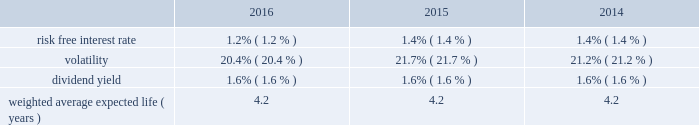Fidelity national information services , inc .
And subsidiaries notes to consolidated financial statements - ( continued ) ( a ) intrinsic value is based on a closing stock price as of december 31 , 2016 of $ 75.64 .
The weighted average fair value of options granted during the years ended december 31 , 2016 , 2015 and 2014 was estimated to be $ 9.35 , $ 10.67 and $ 9.15 , respectively , using the black-scholes option pricing model with the assumptions below: .
The company estimates future forfeitures at the time of grant and revises those estimates in subsequent periods if actual forfeitures differ from those estimates .
The company bases the risk-free interest rate that is used in the stock option valuation model on u.s .
N treasury securities issued with maturities similar to the expected term of the options .
The expected stock volatility factor is determined using historical daily price changes of the company's common stock over the most recent period commensurate with the expected term of the option and the impact of any expected trends .
The dividend yield assumption is based on the current dividend yield at the grant tt date or management's forecasted expectations .
The expected life assumption is determined by calculating the average term from the tt company's historical stock option activity and considering the impact of expected future trends .
The company granted a total of 1 million restricted stock shares at prices ranging from $ 56.44 to $ 79.41 on various dates in 2016 .
The company granted a total of 1 million restricted stock shares at prices ranging from $ 61.33 to $ 69.33 on various dates in 20t 15 .
The company granted a total of 1 million restricted stock shares at prices ranging from $ 52.85 to $ 64.04 on various dates in 2014 .
These shares were granted at the closing market price on the date of grant and vest annually over three years .
As of december 31 , 2016 and 2015 , we have approximately 3 million and 4 million unvested restricted shares remaining .
The december 31 , 2016 balance includes those rsu's converted in connection with the sungard acquisition as noted above .
The company has provided for total stock compensation expense of $ 137 million , $ 98 million and $ 56 million for the years ended december 31 , 2016 , 2015 and 2014 , respectively , which is included in selling , general , and administrative expense in the consolidated statements of earnings , unless the expense is attributable to a discontinued operation .
Of the total stock compensation expense , $ 2 million for 2014 relates to liability based awards that will not be credited to additional paid in capital until issued .
Total d compensation expense for 2016 and 2015 did not include amounts relating to liability based awards .
As of december 31 , 2016 and 2015 , the total unrecognized compensation cost related to non-vested stock awards is $ 141 million and $ 206 million , respectively , which is expected to be recognized in pre-tax income over a weighted average period of 1.4 years and 1.6 years , respectively .
German pension plans our german operations have unfunded , defined benefit plan obligations .
These obligations relate to benefits to be paid to germanaa employees upon retirement .
The accumulated benefit obligation as of december 31 , 2016 and 2015 , was $ 49 million and $ 48 million , respectively , and the projected benefit obligation was $ 50 million and $ 49 million , respectively .
The plan remains unfunded as of december 31 , 2016 .
( 15 ) divestitures and discontinued operations on december 7 , 2016 , the company entered into a definitive agreement to sell the sungard public sector and education ( "ps&e" ) businesses for $ 850 million .
The transaction included all ps&e solutions , which provide a comprehensive set of technology solutions to address public safety and public administration needs of government entities as well asn the needs of k-12 school districts .
The divestiture is consistent with our strategy to serve the financial services markets .
We received cash proceeds , net of taxes and transaction-related expenses of approximately $ 500 million .
Net cash proceeds are expected to be used to reduce outstanding debt ( see note 10 ) .
The ps&e businesses are included in the corporate and other segment .
The transaction closed on february 1 , 2017 , resulting in an expected pre-tax gain ranging from $ 85 million to $ 90 million that will .
What is the percentage increase in the fair value of of options from 2015 to 2016? 
Computations: ((9.35 - 10.67) / 10.67)
Answer: -0.12371. Fidelity national information services , inc .
And subsidiaries notes to consolidated financial statements - ( continued ) ( a ) intrinsic value is based on a closing stock price as of december 31 , 2016 of $ 75.64 .
The weighted average fair value of options granted during the years ended december 31 , 2016 , 2015 and 2014 was estimated to be $ 9.35 , $ 10.67 and $ 9.15 , respectively , using the black-scholes option pricing model with the assumptions below: .
The company estimates future forfeitures at the time of grant and revises those estimates in subsequent periods if actual forfeitures differ from those estimates .
The company bases the risk-free interest rate that is used in the stock option valuation model on u.s .
N treasury securities issued with maturities similar to the expected term of the options .
The expected stock volatility factor is determined using historical daily price changes of the company's common stock over the most recent period commensurate with the expected term of the option and the impact of any expected trends .
The dividend yield assumption is based on the current dividend yield at the grant tt date or management's forecasted expectations .
The expected life assumption is determined by calculating the average term from the tt company's historical stock option activity and considering the impact of expected future trends .
The company granted a total of 1 million restricted stock shares at prices ranging from $ 56.44 to $ 79.41 on various dates in 2016 .
The company granted a total of 1 million restricted stock shares at prices ranging from $ 61.33 to $ 69.33 on various dates in 20t 15 .
The company granted a total of 1 million restricted stock shares at prices ranging from $ 52.85 to $ 64.04 on various dates in 2014 .
These shares were granted at the closing market price on the date of grant and vest annually over three years .
As of december 31 , 2016 and 2015 , we have approximately 3 million and 4 million unvested restricted shares remaining .
The december 31 , 2016 balance includes those rsu's converted in connection with the sungard acquisition as noted above .
The company has provided for total stock compensation expense of $ 137 million , $ 98 million and $ 56 million for the years ended december 31 , 2016 , 2015 and 2014 , respectively , which is included in selling , general , and administrative expense in the consolidated statements of earnings , unless the expense is attributable to a discontinued operation .
Of the total stock compensation expense , $ 2 million for 2014 relates to liability based awards that will not be credited to additional paid in capital until issued .
Total d compensation expense for 2016 and 2015 did not include amounts relating to liability based awards .
As of december 31 , 2016 and 2015 , the total unrecognized compensation cost related to non-vested stock awards is $ 141 million and $ 206 million , respectively , which is expected to be recognized in pre-tax income over a weighted average period of 1.4 years and 1.6 years , respectively .
German pension plans our german operations have unfunded , defined benefit plan obligations .
These obligations relate to benefits to be paid to germanaa employees upon retirement .
The accumulated benefit obligation as of december 31 , 2016 and 2015 , was $ 49 million and $ 48 million , respectively , and the projected benefit obligation was $ 50 million and $ 49 million , respectively .
The plan remains unfunded as of december 31 , 2016 .
( 15 ) divestitures and discontinued operations on december 7 , 2016 , the company entered into a definitive agreement to sell the sungard public sector and education ( "ps&e" ) businesses for $ 850 million .
The transaction included all ps&e solutions , which provide a comprehensive set of technology solutions to address public safety and public administration needs of government entities as well asn the needs of k-12 school districts .
The divestiture is consistent with our strategy to serve the financial services markets .
We received cash proceeds , net of taxes and transaction-related expenses of approximately $ 500 million .
Net cash proceeds are expected to be used to reduce outstanding debt ( see note 10 ) .
The ps&e businesses are included in the corporate and other segment .
The transaction closed on february 1 , 2017 , resulting in an expected pre-tax gain ranging from $ 85 million to $ 90 million that will .
What was the difference in millions of the accumulated benefit obligation as of december 31 , 2016 versus the projected benefit obligation? 
Rationale: looking to see if there is a large unfunded obligation hanging out there .
Computations: (49 - 50)
Answer: -1.0. 